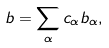Convert formula to latex. <formula><loc_0><loc_0><loc_500><loc_500>b = \sum _ { \alpha } c _ { \alpha } b _ { \alpha } ,</formula> 